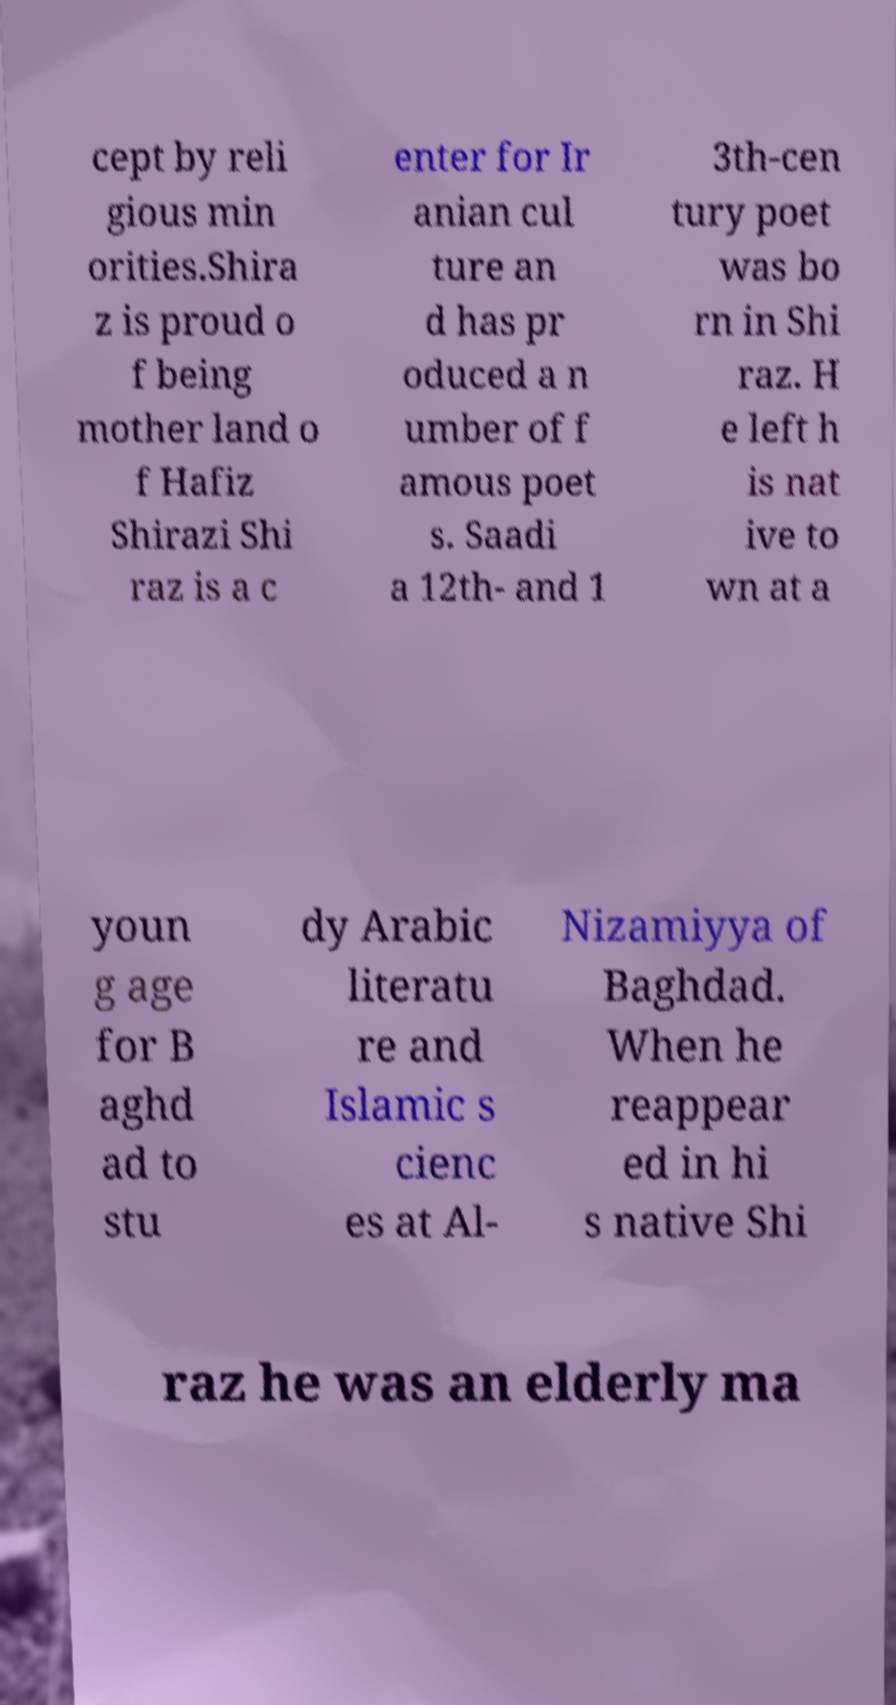Could you assist in decoding the text presented in this image and type it out clearly? cept by reli gious min orities.Shira z is proud o f being mother land o f Hafiz Shirazi Shi raz is a c enter for Ir anian cul ture an d has pr oduced a n umber of f amous poet s. Saadi a 12th- and 1 3th-cen tury poet was bo rn in Shi raz. H e left h is nat ive to wn at a youn g age for B aghd ad to stu dy Arabic literatu re and Islamic s cienc es at Al- Nizamiyya of Baghdad. When he reappear ed in hi s native Shi raz he was an elderly ma 